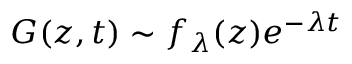Convert formula to latex. <formula><loc_0><loc_0><loc_500><loc_500>G ( z , t ) \sim f _ { \lambda } ( z ) e ^ { - \lambda t }</formula> 